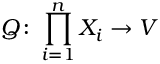<formula> <loc_0><loc_0><loc_500><loc_500>Q \colon \prod _ { i = 1 } ^ { n } X _ { i } \to V</formula> 